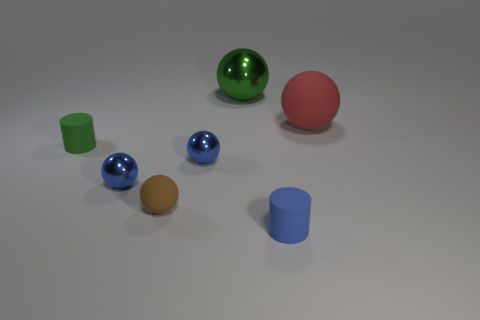How many shiny things are there?
Your answer should be compact. 3. There is a shiny thing that is right of the tiny matte ball and in front of the green sphere; what is its shape?
Give a very brief answer. Sphere. Does the cylinder that is to the left of the tiny blue matte cylinder have the same color as the metal thing behind the green matte object?
Provide a succinct answer. Yes. Are there any tiny brown things that have the same material as the red thing?
Provide a short and direct response. Yes. Is the number of small blue things that are behind the red sphere the same as the number of large red objects that are behind the big green object?
Your answer should be compact. Yes. How big is the matte cylinder that is on the left side of the brown thing?
Your answer should be compact. Small. What material is the large thing to the right of the small matte cylinder that is in front of the small green matte cylinder?
Offer a very short reply. Rubber. There is a large ball in front of the sphere that is behind the red matte object; how many red rubber spheres are in front of it?
Your answer should be compact. 0. Is the material of the cylinder that is in front of the tiny brown ball the same as the big thing left of the tiny blue matte object?
Offer a very short reply. No. How many green metallic things are the same shape as the blue rubber thing?
Your answer should be compact. 0. 